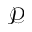Convert formula to latex. <formula><loc_0><loc_0><loc_500><loc_500>\mathcal { P }</formula> 